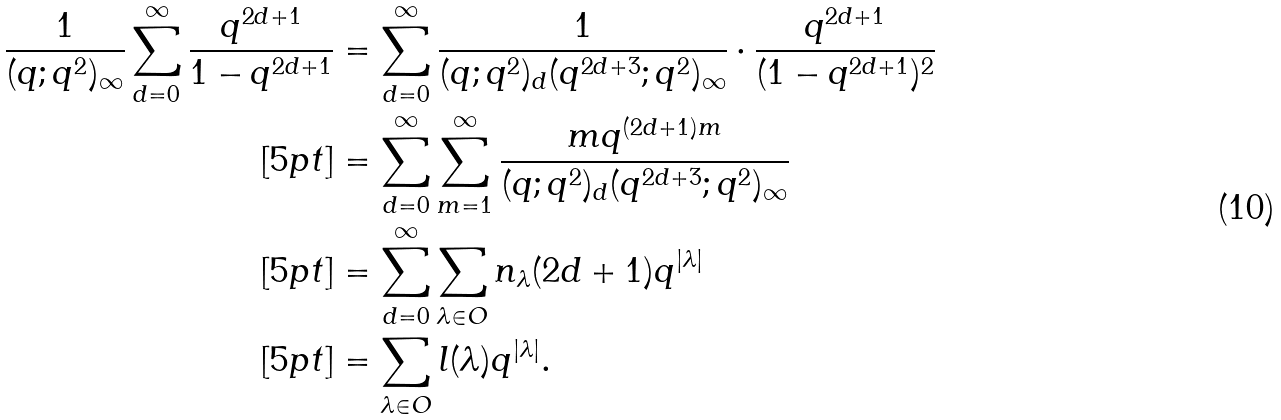<formula> <loc_0><loc_0><loc_500><loc_500>\frac { 1 } { ( q ; q ^ { 2 } ) _ { \infty } } \sum _ { d = 0 } ^ { \infty } \frac { q ^ { 2 d + 1 } } { 1 - q ^ { 2 d + 1 } } & = \sum _ { d = 0 } ^ { \infty } \frac { 1 } { ( q ; q ^ { 2 } ) _ { d } ( q ^ { 2 d + 3 } ; q ^ { 2 } ) _ { \infty } } \cdot \frac { q ^ { 2 d + 1 } } { ( 1 - q ^ { 2 d + 1 } ) ^ { 2 } } \\ [ 5 p t ] & = \sum _ { d = 0 } ^ { \infty } \sum _ { m = 1 } ^ { \infty } \frac { m q ^ { ( 2 d + 1 ) m } } { ( q ; q ^ { 2 } ) _ { d } ( q ^ { 2 d + 3 } ; q ^ { 2 } ) _ { \infty } } \\ [ 5 p t ] & = \sum _ { d = 0 } ^ { \infty } \sum _ { \lambda \in O } n _ { \lambda } ( 2 d + 1 ) q ^ { | \lambda | } \\ [ 5 p t ] & = \sum _ { \lambda \in O } l ( \lambda ) q ^ { | \lambda | } .</formula> 